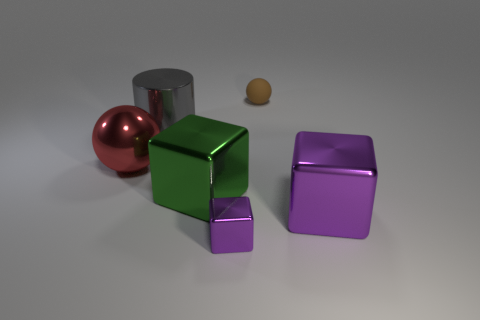There is a cube that is on the right side of the rubber object; what material is it? metal 